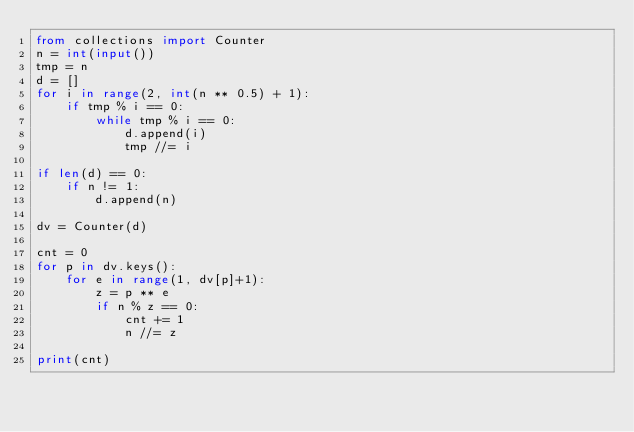<code> <loc_0><loc_0><loc_500><loc_500><_Python_>from collections import Counter
n = int(input())
tmp = n
d = []
for i in range(2, int(n ** 0.5) + 1):
    if tmp % i == 0:
        while tmp % i == 0:
            d.append(i)
            tmp //= i

if len(d) == 0:
    if n != 1:
        d.append(n)

dv = Counter(d)

cnt = 0
for p in dv.keys():
    for e in range(1, dv[p]+1):
        z = p ** e
        if n % z == 0:
            cnt += 1
            n //= z

print(cnt)
</code> 